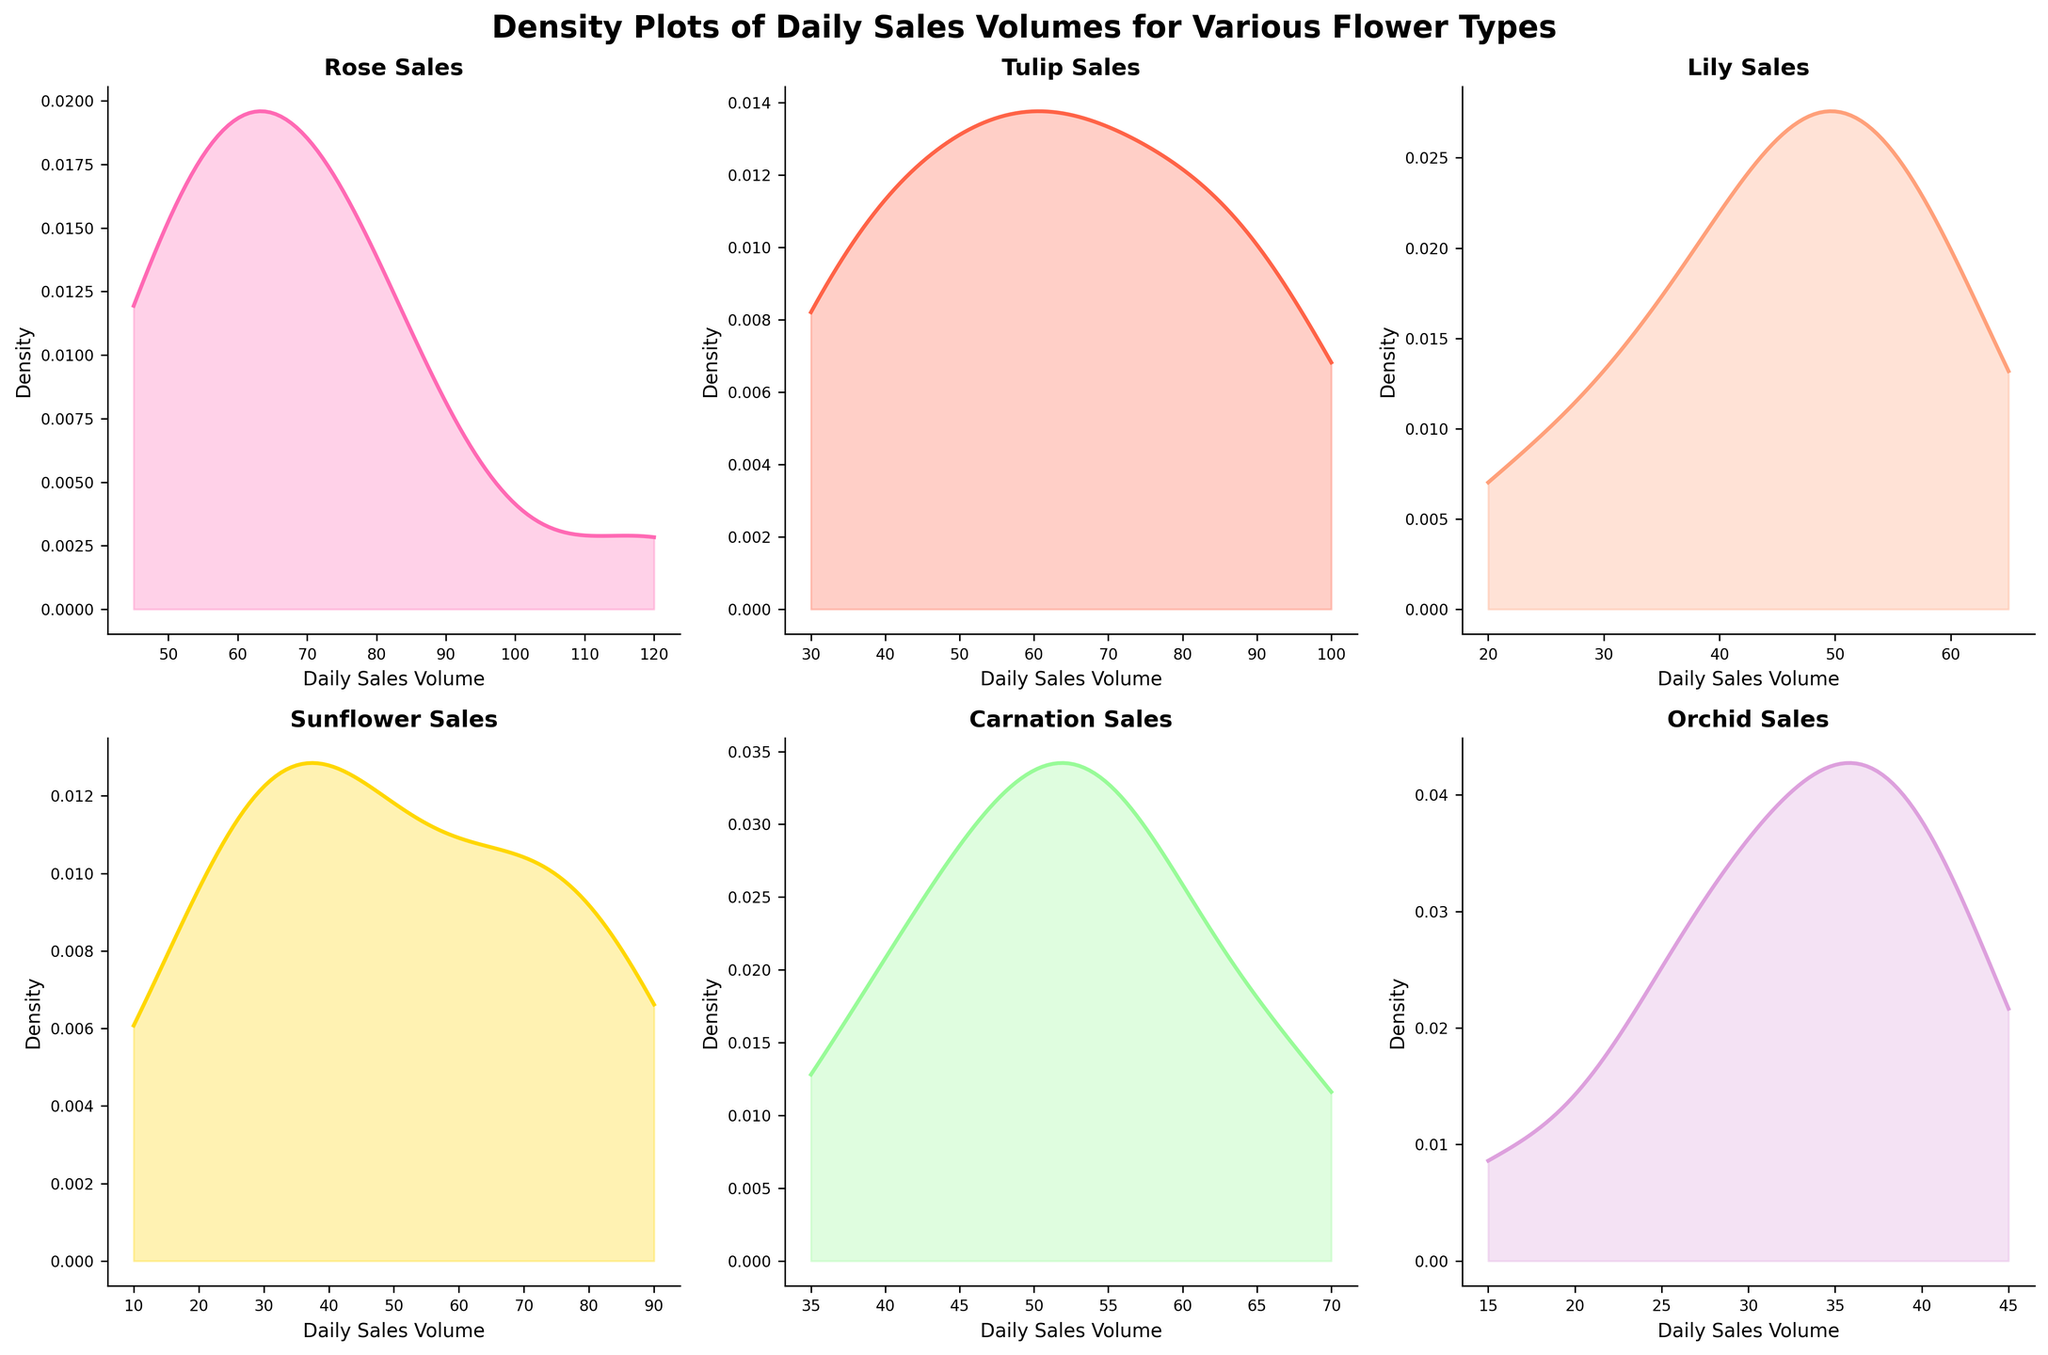What is the title of the figure? The title of the figure is directly stated at the top of the plot.
Answer: Density Plots of Daily Sales Volumes for Various Flower Types Which flower has the highest peak density value? To determine the highest peak density value, inspect the plots to see which flower has the tallest peak.
Answer: Tulip Which flower has the broadest range of daily sales volumes? A broader range is indicated by a wider base of the density plot. Inspect each plot to see which has the most spread out along the x-axis.
Answer: Sunflower Are the Rose and Lily sales distribution similar? Compare the density plots of Rose and Lily to check if their shapes and ranges are similar.
Answer: No Which flower has the smallest peak density value? Identify the flower by looking for the density plot with the shortest peak.
Answer: Orchid Is the peak density value of Carnation higher or lower than that of Rose? Compare the peak heights of Carnation and Rose density plots.
Answer: Lower Which flower shows two or more modes in its sales distribution? A multimodal distribution will have more than one peak. Check the plots for this characteristic.
Answer: None Which flower has a sharper peak, Tulip or Sunflower? A sharper peak is narrower and taller. Compare the Tulip and Sunflower plots to see which is sharper.
Answer: Tulip Between Tulip and Orchid, which has a wider spread in sales volumes? A wider spread means a broader base. Compare the width of the density plot bases for Tulip and Orchid.
Answer: Tulip What is the x-axis label used in the plot? The x-axis label is clearly shown on each subplot, representing the horizontal axis.
Answer: Daily Sales Volume 